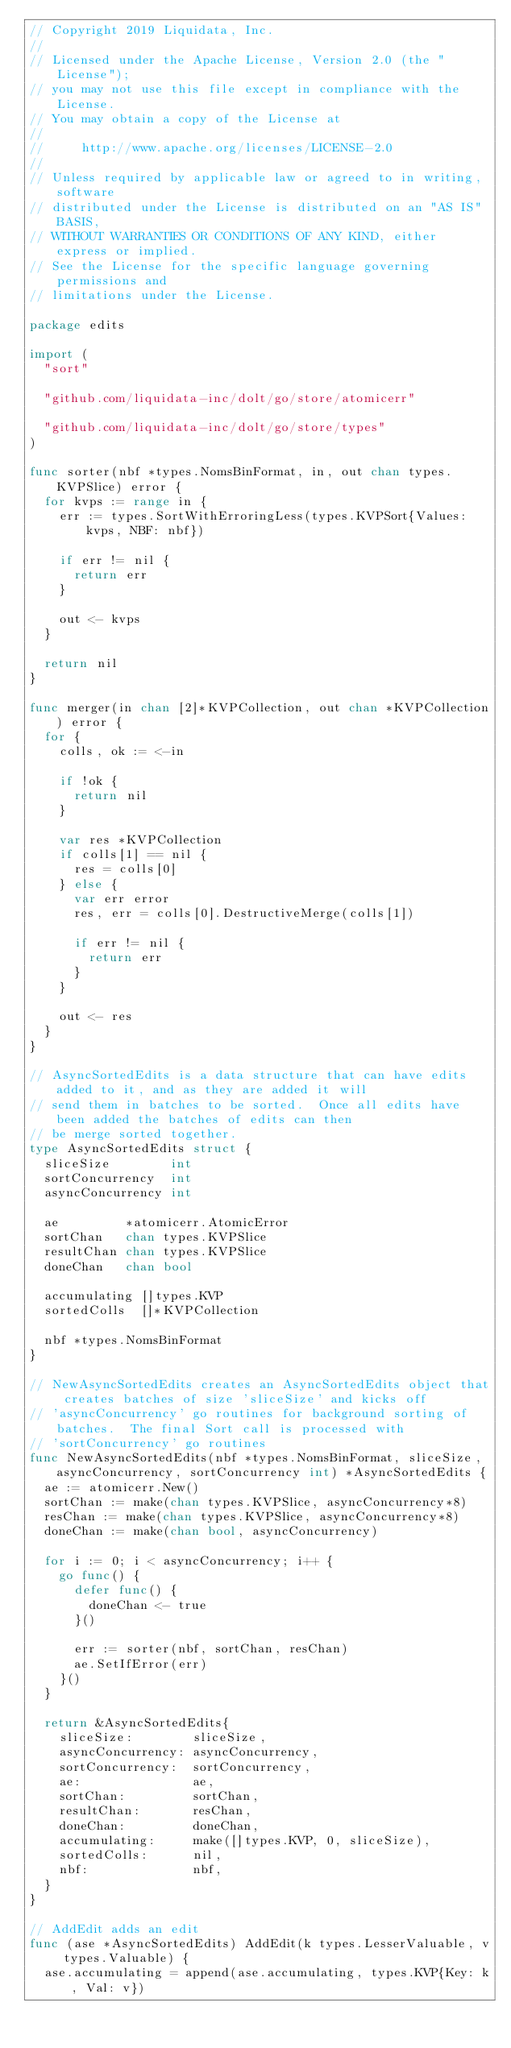<code> <loc_0><loc_0><loc_500><loc_500><_Go_>// Copyright 2019 Liquidata, Inc.
//
// Licensed under the Apache License, Version 2.0 (the "License");
// you may not use this file except in compliance with the License.
// You may obtain a copy of the License at
//
//     http://www.apache.org/licenses/LICENSE-2.0
//
// Unless required by applicable law or agreed to in writing, software
// distributed under the License is distributed on an "AS IS" BASIS,
// WITHOUT WARRANTIES OR CONDITIONS OF ANY KIND, either express or implied.
// See the License for the specific language governing permissions and
// limitations under the License.

package edits

import (
	"sort"

	"github.com/liquidata-inc/dolt/go/store/atomicerr"

	"github.com/liquidata-inc/dolt/go/store/types"
)

func sorter(nbf *types.NomsBinFormat, in, out chan types.KVPSlice) error {
	for kvps := range in {
		err := types.SortWithErroringLess(types.KVPSort{Values: kvps, NBF: nbf})

		if err != nil {
			return err
		}

		out <- kvps
	}

	return nil
}

func merger(in chan [2]*KVPCollection, out chan *KVPCollection) error {
	for {
		colls, ok := <-in

		if !ok {
			return nil
		}

		var res *KVPCollection
		if colls[1] == nil {
			res = colls[0]
		} else {
			var err error
			res, err = colls[0].DestructiveMerge(colls[1])

			if err != nil {
				return err
			}
		}

		out <- res
	}
}

// AsyncSortedEdits is a data structure that can have edits added to it, and as they are added it will
// send them in batches to be sorted.  Once all edits have been added the batches of edits can then
// be merge sorted together.
type AsyncSortedEdits struct {
	sliceSize        int
	sortConcurrency  int
	asyncConcurrency int

	ae         *atomicerr.AtomicError
	sortChan   chan types.KVPSlice
	resultChan chan types.KVPSlice
	doneChan   chan bool

	accumulating []types.KVP
	sortedColls  []*KVPCollection

	nbf *types.NomsBinFormat
}

// NewAsyncSortedEdits creates an AsyncSortedEdits object that creates batches of size 'sliceSize' and kicks off
// 'asyncConcurrency' go routines for background sorting of batches.  The final Sort call is processed with
// 'sortConcurrency' go routines
func NewAsyncSortedEdits(nbf *types.NomsBinFormat, sliceSize, asyncConcurrency, sortConcurrency int) *AsyncSortedEdits {
	ae := atomicerr.New()
	sortChan := make(chan types.KVPSlice, asyncConcurrency*8)
	resChan := make(chan types.KVPSlice, asyncConcurrency*8)
	doneChan := make(chan bool, asyncConcurrency)

	for i := 0; i < asyncConcurrency; i++ {
		go func() {
			defer func() {
				doneChan <- true
			}()

			err := sorter(nbf, sortChan, resChan)
			ae.SetIfError(err)
		}()
	}

	return &AsyncSortedEdits{
		sliceSize:        sliceSize,
		asyncConcurrency: asyncConcurrency,
		sortConcurrency:  sortConcurrency,
		ae:               ae,
		sortChan:         sortChan,
		resultChan:       resChan,
		doneChan:         doneChan,
		accumulating:     make([]types.KVP, 0, sliceSize),
		sortedColls:      nil,
		nbf:              nbf,
	}
}

// AddEdit adds an edit
func (ase *AsyncSortedEdits) AddEdit(k types.LesserValuable, v types.Valuable) {
	ase.accumulating = append(ase.accumulating, types.KVP{Key: k, Val: v})
</code> 